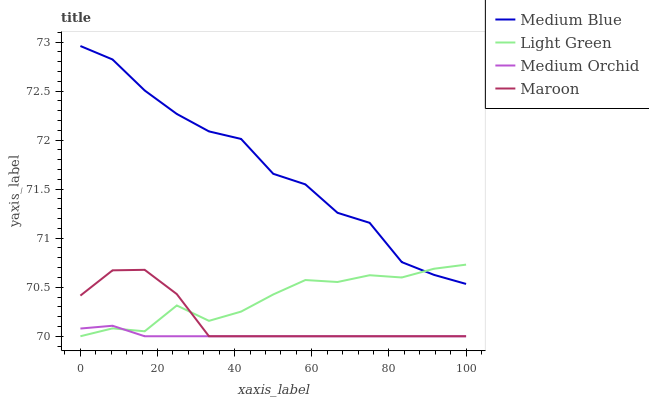Does Medium Orchid have the minimum area under the curve?
Answer yes or no. Yes. Does Medium Blue have the maximum area under the curve?
Answer yes or no. Yes. Does Maroon have the minimum area under the curve?
Answer yes or no. No. Does Maroon have the maximum area under the curve?
Answer yes or no. No. Is Medium Orchid the smoothest?
Answer yes or no. Yes. Is Medium Blue the roughest?
Answer yes or no. Yes. Is Maroon the smoothest?
Answer yes or no. No. Is Maroon the roughest?
Answer yes or no. No. Does Medium Orchid have the lowest value?
Answer yes or no. Yes. Does Medium Blue have the lowest value?
Answer yes or no. No. Does Medium Blue have the highest value?
Answer yes or no. Yes. Does Maroon have the highest value?
Answer yes or no. No. Is Maroon less than Medium Blue?
Answer yes or no. Yes. Is Medium Blue greater than Medium Orchid?
Answer yes or no. Yes. Does Medium Orchid intersect Maroon?
Answer yes or no. Yes. Is Medium Orchid less than Maroon?
Answer yes or no. No. Is Medium Orchid greater than Maroon?
Answer yes or no. No. Does Maroon intersect Medium Blue?
Answer yes or no. No. 